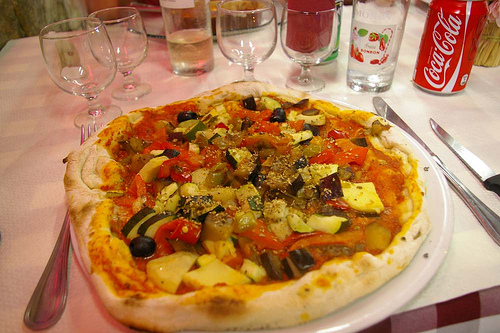What types of vegetables can be seen on the pizza in the image? The pizza is lavishly topped with a variety of vegetables including zucchini, peppers, black olives, and diced tomatoes, each contributing its own burst of flavor and color. 